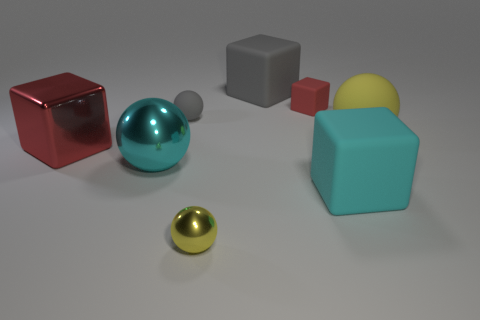Subtract 2 blocks. How many blocks are left? 2 Subtract all matte cubes. How many cubes are left? 1 Subtract all brown spheres. Subtract all gray cylinders. How many spheres are left? 4 Add 1 tiny blue matte objects. How many objects exist? 9 Add 7 cyan metallic balls. How many cyan metallic balls are left? 8 Add 3 matte things. How many matte things exist? 8 Subtract 1 yellow spheres. How many objects are left? 7 Subtract all purple matte cylinders. Subtract all red matte things. How many objects are left? 7 